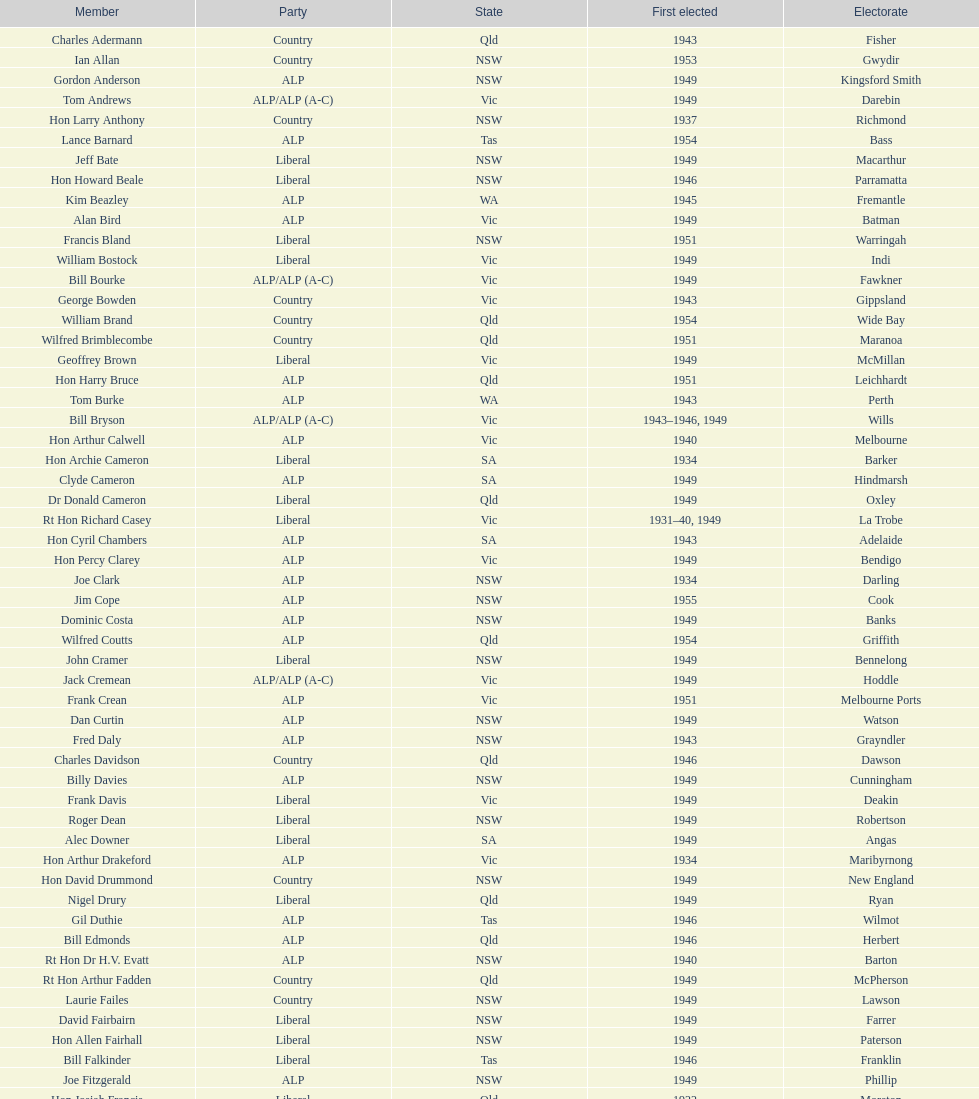After tom burke was elected, what was the next year where another tom would be elected? 1937. 